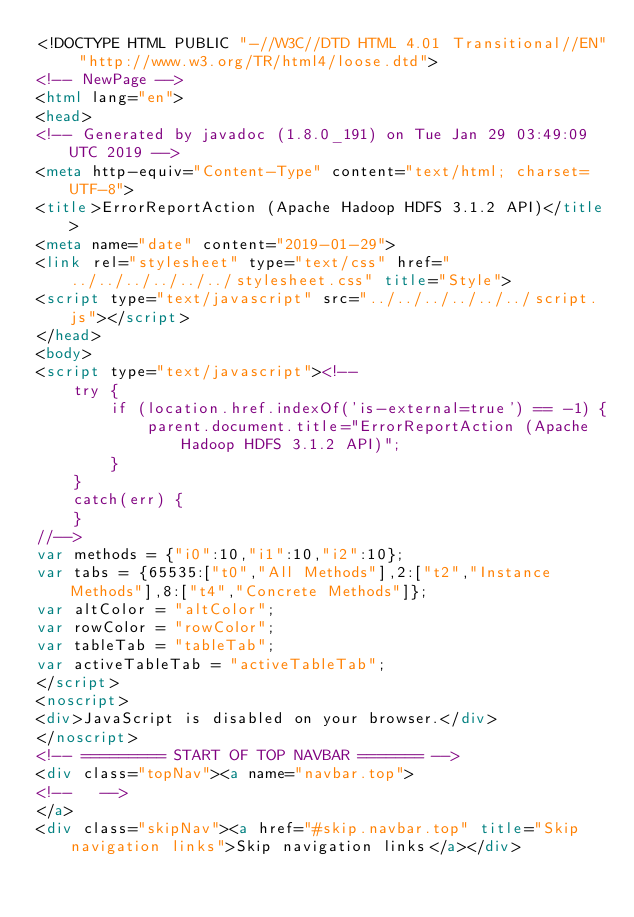<code> <loc_0><loc_0><loc_500><loc_500><_HTML_><!DOCTYPE HTML PUBLIC "-//W3C//DTD HTML 4.01 Transitional//EN" "http://www.w3.org/TR/html4/loose.dtd">
<!-- NewPage -->
<html lang="en">
<head>
<!-- Generated by javadoc (1.8.0_191) on Tue Jan 29 03:49:09 UTC 2019 -->
<meta http-equiv="Content-Type" content="text/html; charset=UTF-8">
<title>ErrorReportAction (Apache Hadoop HDFS 3.1.2 API)</title>
<meta name="date" content="2019-01-29">
<link rel="stylesheet" type="text/css" href="../../../../../../stylesheet.css" title="Style">
<script type="text/javascript" src="../../../../../../script.js"></script>
</head>
<body>
<script type="text/javascript"><!--
    try {
        if (location.href.indexOf('is-external=true') == -1) {
            parent.document.title="ErrorReportAction (Apache Hadoop HDFS 3.1.2 API)";
        }
    }
    catch(err) {
    }
//-->
var methods = {"i0":10,"i1":10,"i2":10};
var tabs = {65535:["t0","All Methods"],2:["t2","Instance Methods"],8:["t4","Concrete Methods"]};
var altColor = "altColor";
var rowColor = "rowColor";
var tableTab = "tableTab";
var activeTableTab = "activeTableTab";
</script>
<noscript>
<div>JavaScript is disabled on your browser.</div>
</noscript>
<!-- ========= START OF TOP NAVBAR ======= -->
<div class="topNav"><a name="navbar.top">
<!--   -->
</a>
<div class="skipNav"><a href="#skip.navbar.top" title="Skip navigation links">Skip navigation links</a></div></code> 